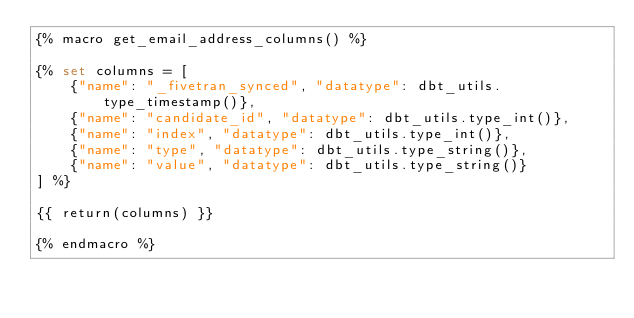<code> <loc_0><loc_0><loc_500><loc_500><_SQL_>{% macro get_email_address_columns() %}

{% set columns = [
    {"name": "_fivetran_synced", "datatype": dbt_utils.type_timestamp()},
    {"name": "candidate_id", "datatype": dbt_utils.type_int()},
    {"name": "index", "datatype": dbt_utils.type_int()},
    {"name": "type", "datatype": dbt_utils.type_string()},
    {"name": "value", "datatype": dbt_utils.type_string()}
] %}

{{ return(columns) }}

{% endmacro %}
</code> 